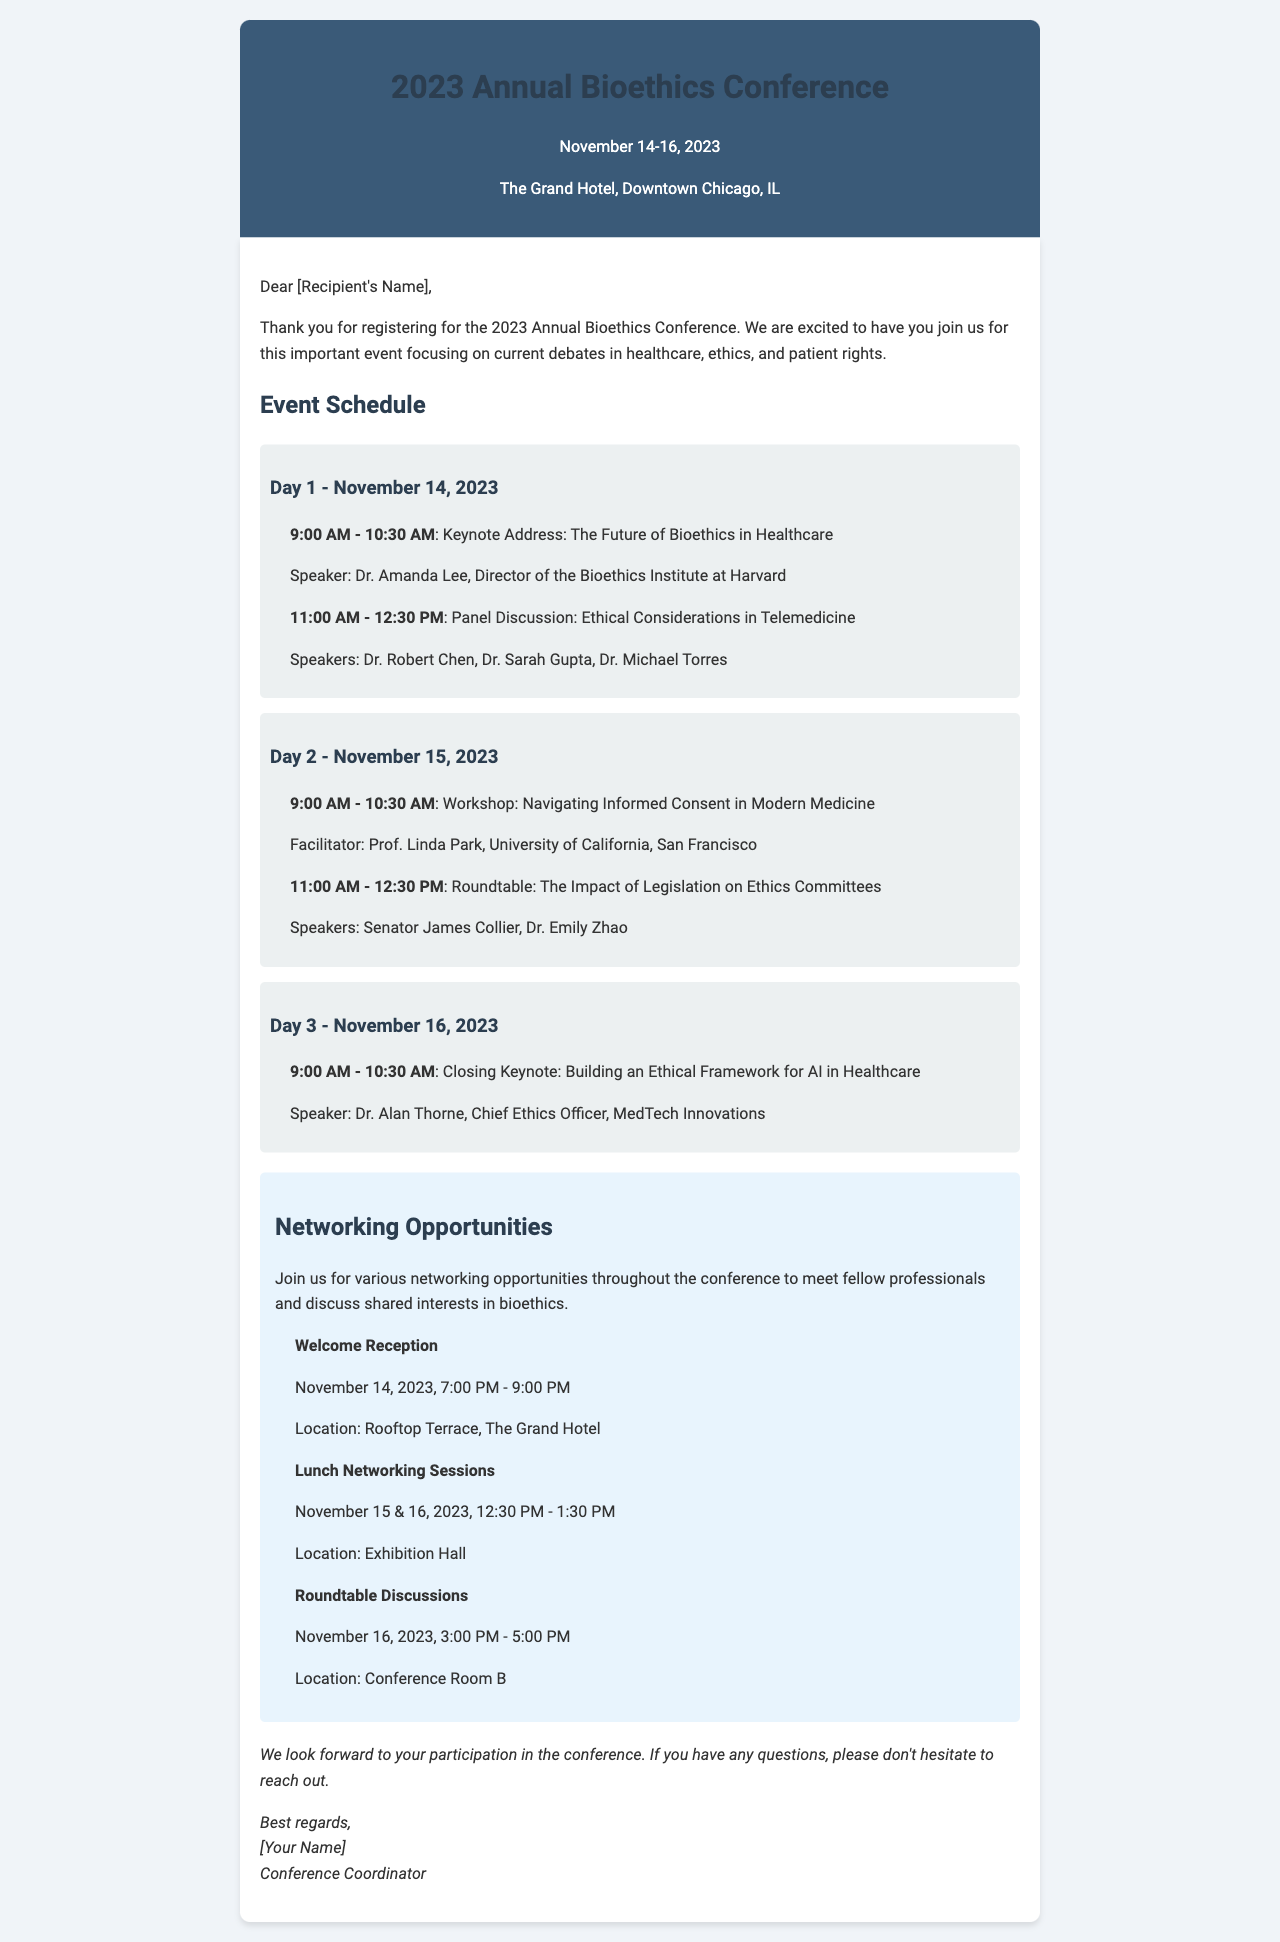What are the conference dates? The conference dates are specified in the header of the document, which is November 14-16, 2023.
Answer: November 14-16, 2023 Who is the keynote speaker on Day 1? The keynote speaker for Day 1 is listed in the schedule section, specifically for the session at 9:00 AM on November 14, which is Dr. Amanda Lee.
Answer: Dr. Amanda Lee What time does the Welcome Reception start? The start time for the Welcome Reception is mentioned under the Networking Opportunities section, which is 7:00 PM.
Answer: 7:00 PM What is the location of the Roundtable Discussions? The location for the Roundtable Discussions is noted in the networking section, specifically for the event on November 16, which is Conference Room B.
Answer: Conference Room B How many keynote addresses are scheduled for the conference? The number of keynote addresses can be inferred from the schedule section where two keynotes are listed, one on Day 1 and one on Day 3.
Answer: 2 What is the topic of the closing keynote? The closing keynote topic is detailed in the schedule for Day 3, which is "Building an Ethical Framework for AI in Healthcare."
Answer: Building an Ethical Framework for AI in Healthcare Who is facilitating the workshop on Day 2? The facilitator for the workshop on Day 2 is indicated in the event schedule, noted for the session at 9:00 AM on November 15, which is Prof. Linda Park.
Answer: Prof. Linda Park On which day are the Lunch Networking Sessions held? The Lunch Networking Sessions are specified to take place on November 15 and 16, as per the networking section.
Answer: November 15 and 16 What is the purpose of the conference? The purpose of the conference is described in the introduction paragraph, focusing on current debates in healthcare, ethics, and patient rights.
Answer: Current debates in healthcare, ethics, and patient rights 